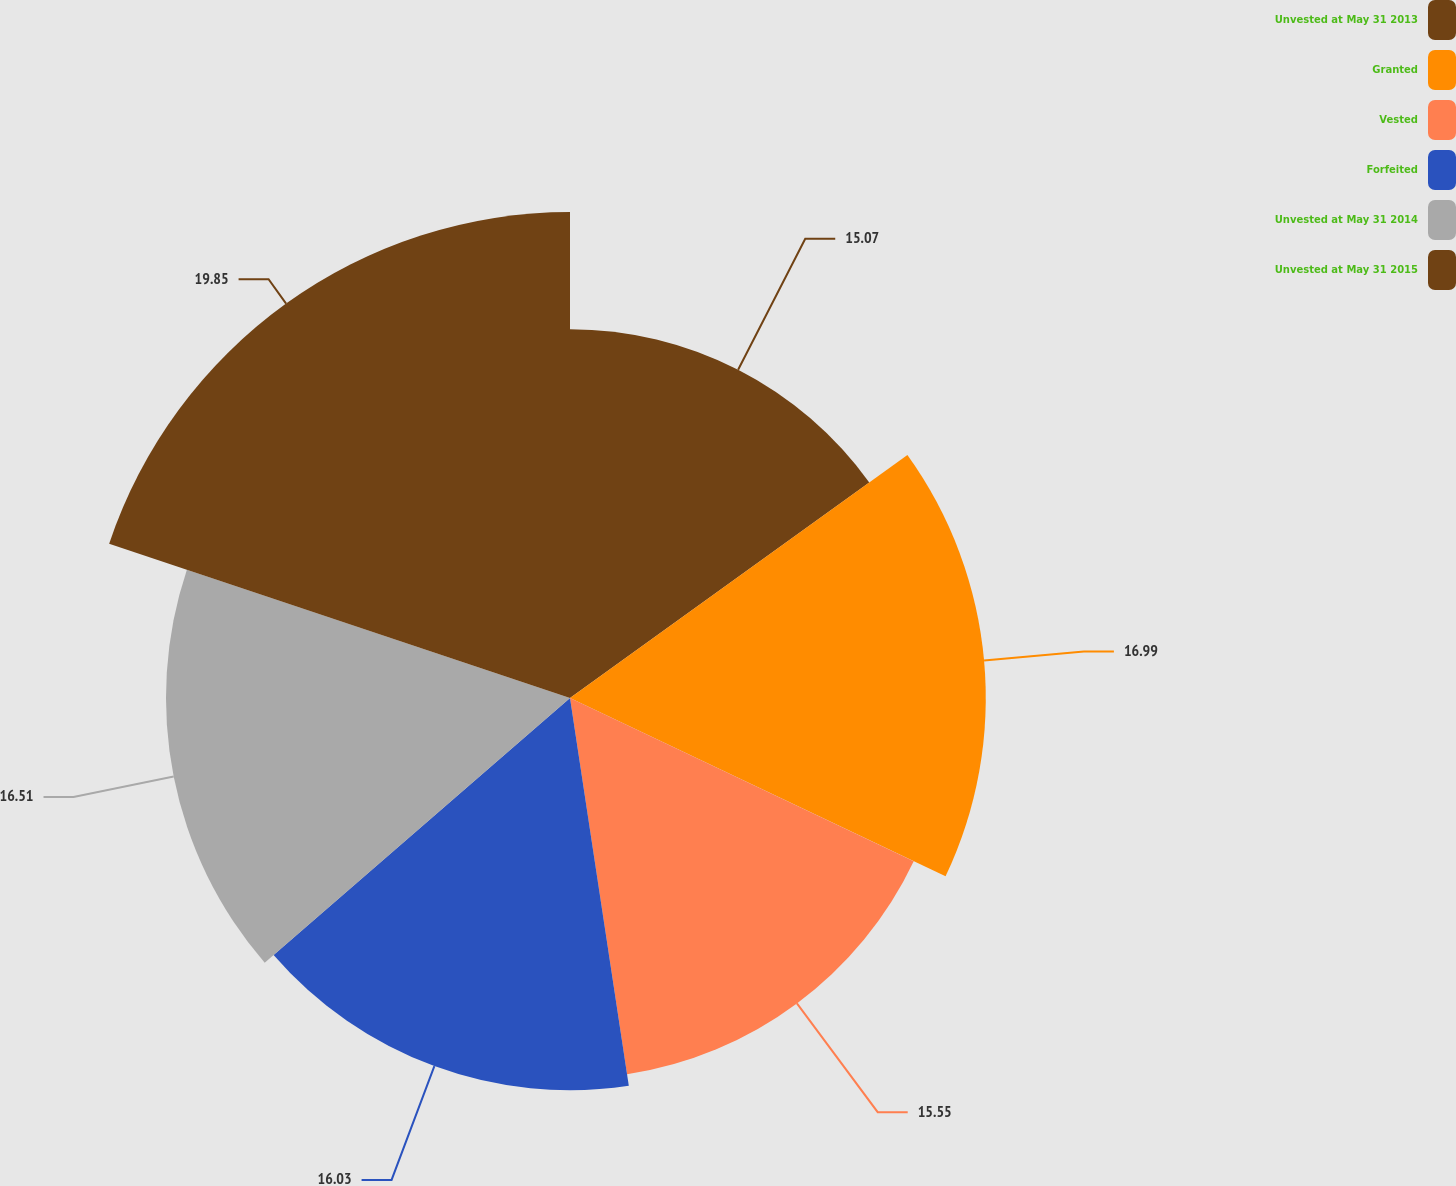Convert chart to OTSL. <chart><loc_0><loc_0><loc_500><loc_500><pie_chart><fcel>Unvested at May 31 2013<fcel>Granted<fcel>Vested<fcel>Forfeited<fcel>Unvested at May 31 2014<fcel>Unvested at May 31 2015<nl><fcel>15.07%<fcel>16.99%<fcel>15.55%<fcel>16.03%<fcel>16.51%<fcel>19.86%<nl></chart> 